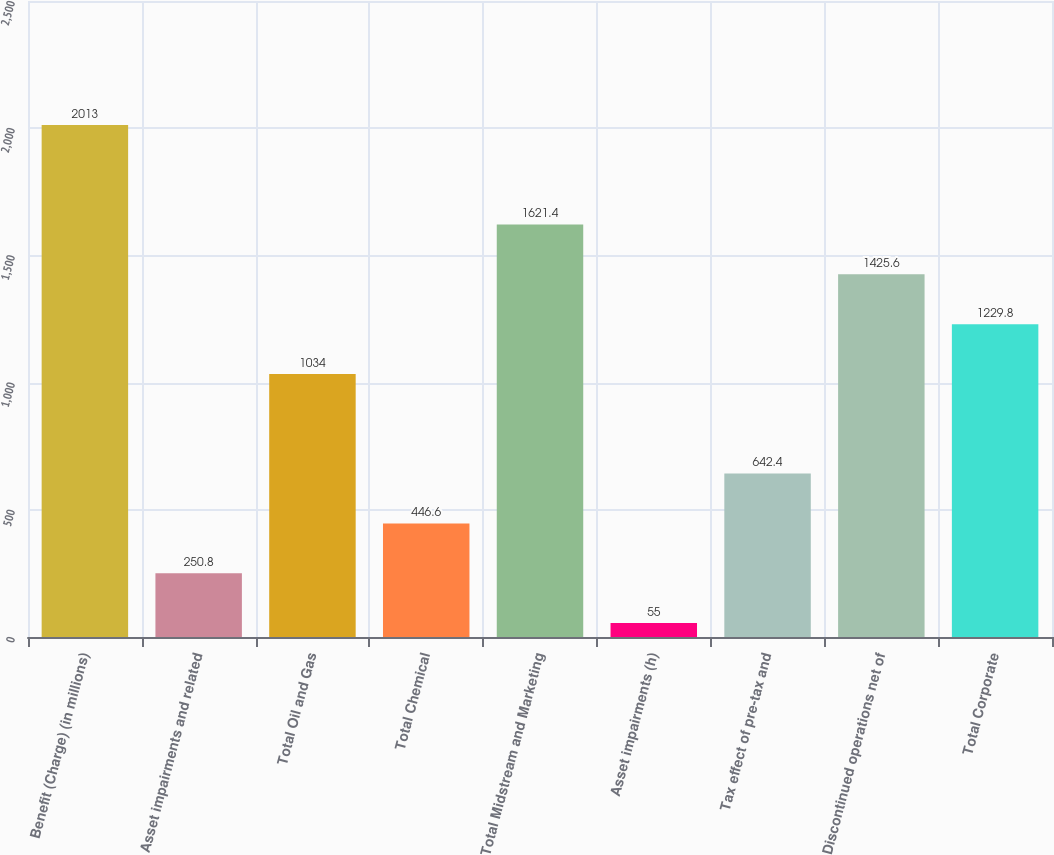Convert chart. <chart><loc_0><loc_0><loc_500><loc_500><bar_chart><fcel>Benefit (Charge) (in millions)<fcel>Asset impairments and related<fcel>Total Oil and Gas<fcel>Total Chemical<fcel>Total Midstream and Marketing<fcel>Asset impairments (h)<fcel>Tax effect of pre-tax and<fcel>Discontinued operations net of<fcel>Total Corporate<nl><fcel>2013<fcel>250.8<fcel>1034<fcel>446.6<fcel>1621.4<fcel>55<fcel>642.4<fcel>1425.6<fcel>1229.8<nl></chart> 